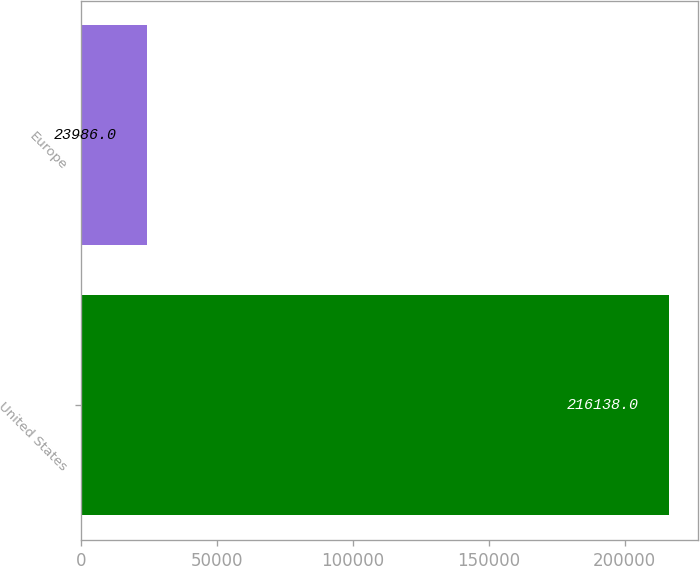<chart> <loc_0><loc_0><loc_500><loc_500><bar_chart><fcel>United States<fcel>Europe<nl><fcel>216138<fcel>23986<nl></chart> 